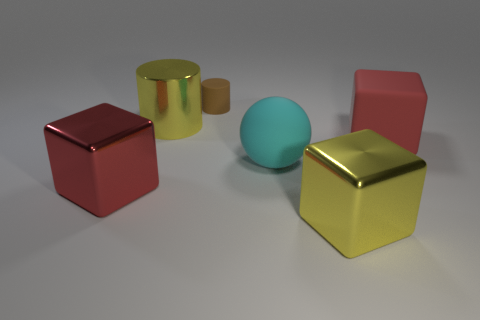Are there any other things that have the same size as the brown cylinder?
Keep it short and to the point. No. How many objects are the same color as the metallic cylinder?
Offer a very short reply. 1. There is a big matte object that is on the left side of the large red matte object; is its color the same as the big shiny object behind the matte cube?
Offer a terse response. No. Are there fewer small brown rubber things that are right of the tiny brown thing than spheres that are in front of the sphere?
Ensure brevity in your answer.  No. Is there anything else that has the same shape as the big red metallic thing?
Make the answer very short. Yes. The other large metal object that is the same shape as the red shiny object is what color?
Provide a succinct answer. Yellow. There is a brown rubber thing; is its shape the same as the large red thing that is left of the large yellow metallic block?
Make the answer very short. No. How many objects are either large yellow metal things in front of the large metallic cylinder or objects that are right of the brown thing?
Offer a terse response. 3. What is the small brown thing made of?
Offer a terse response. Rubber. What number of other objects are there of the same size as the red matte block?
Give a very brief answer. 4. 